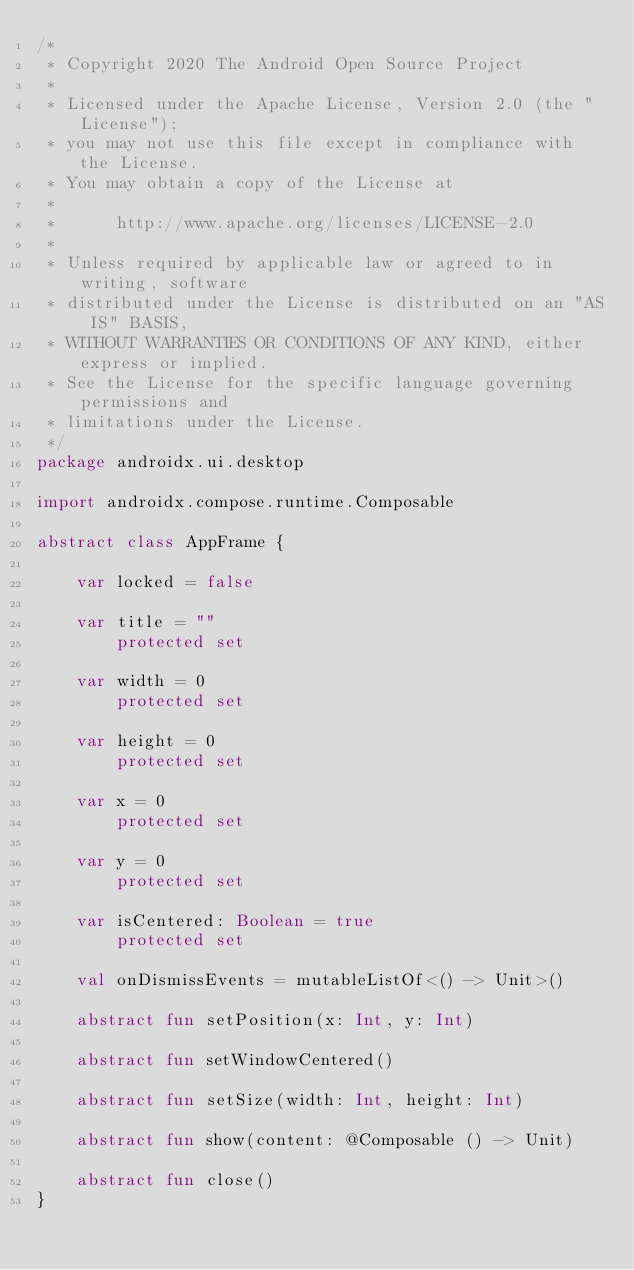<code> <loc_0><loc_0><loc_500><loc_500><_Kotlin_>/*
 * Copyright 2020 The Android Open Source Project
 *
 * Licensed under the Apache License, Version 2.0 (the "License");
 * you may not use this file except in compliance with the License.
 * You may obtain a copy of the License at
 *
 *      http://www.apache.org/licenses/LICENSE-2.0
 *
 * Unless required by applicable law or agreed to in writing, software
 * distributed under the License is distributed on an "AS IS" BASIS,
 * WITHOUT WARRANTIES OR CONDITIONS OF ANY KIND, either express or implied.
 * See the License for the specific language governing permissions and
 * limitations under the License.
 */
package androidx.ui.desktop

import androidx.compose.runtime.Composable

abstract class AppFrame {

    var locked = false

    var title = ""
        protected set

    var width = 0
        protected set

    var height = 0
        protected set

    var x = 0
        protected set

    var y = 0
        protected set

    var isCentered: Boolean = true
        protected set

    val onDismissEvents = mutableListOf<() -> Unit>()

    abstract fun setPosition(x: Int, y: Int)

    abstract fun setWindowCentered()

    abstract fun setSize(width: Int, height: Int)

    abstract fun show(content: @Composable () -> Unit)

    abstract fun close()
}
</code> 